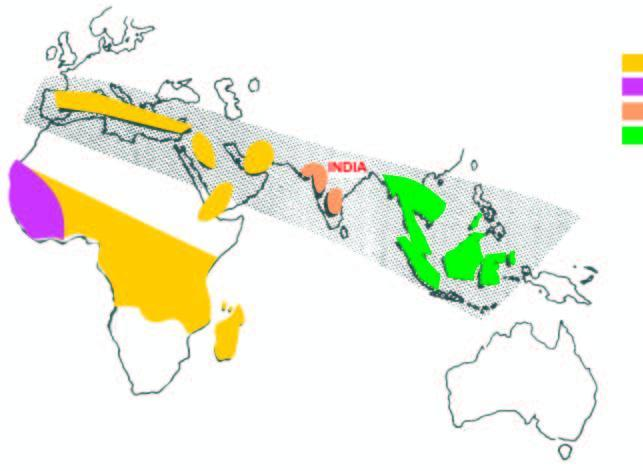re replication of viral dna the haemoglobin disorders common in india?
Answer the question using a single word or phrase. No 